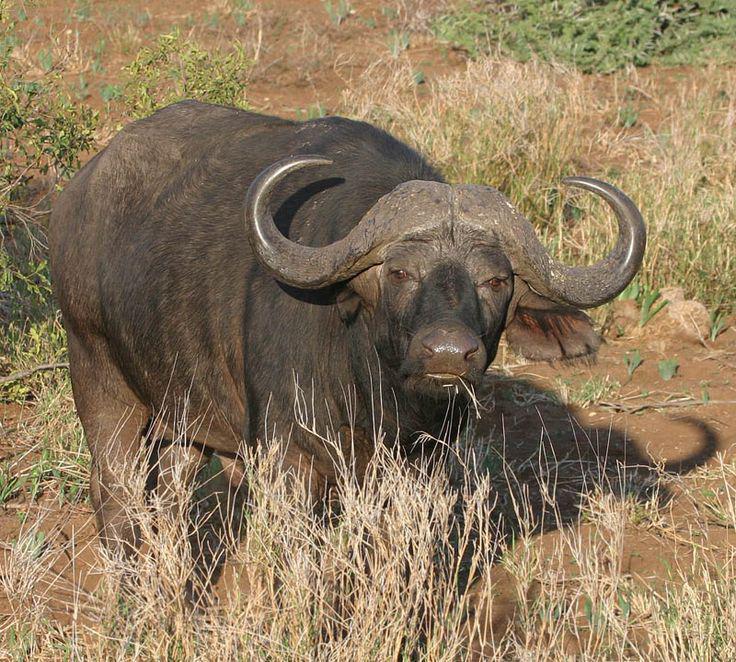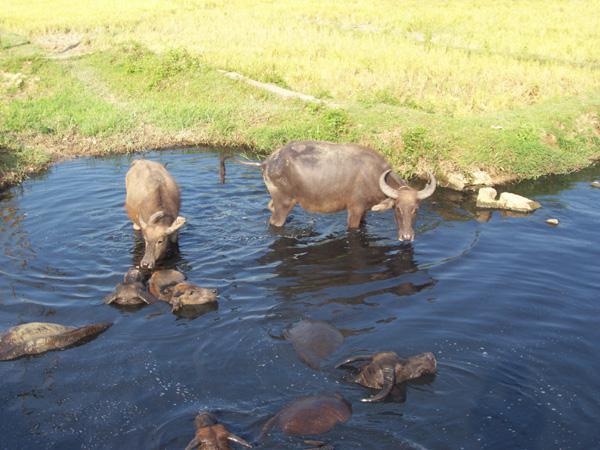The first image is the image on the left, the second image is the image on the right. For the images displayed, is the sentence "In the left image, one horned animal looks directly at the camera." factually correct? Answer yes or no. Yes. The first image is the image on the left, the second image is the image on the right. Assess this claim about the two images: "In one image, animals are standing in water beside a grassy area.". Correct or not? Answer yes or no. Yes. 